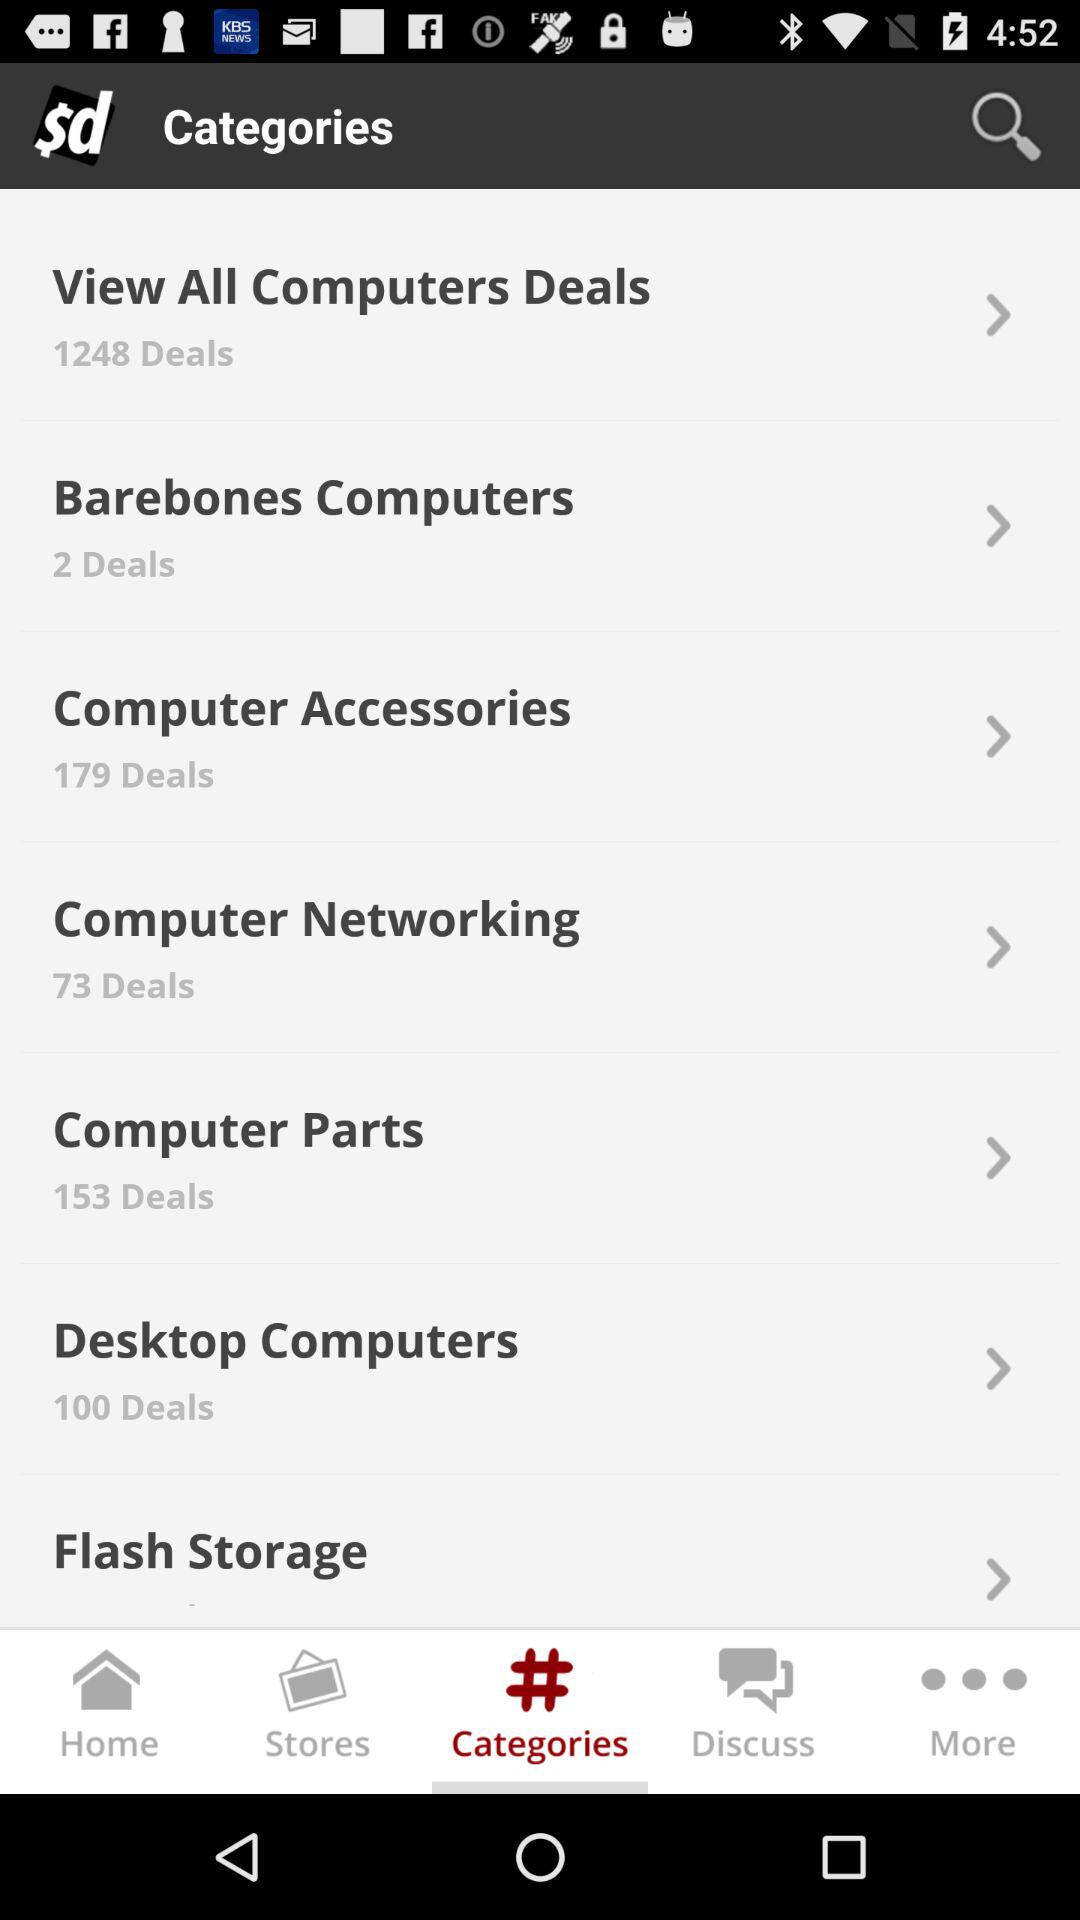How many deals are there in "Barebones Computers"? There are 2 deals. 